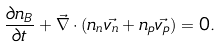<formula> <loc_0><loc_0><loc_500><loc_500>\frac { \partial n _ { B } } { \partial t } + \vec { \nabla } \cdot ( n _ { n } \vec { v _ { n } } + n _ { p } \vec { v _ { p } } ) = 0 .</formula> 